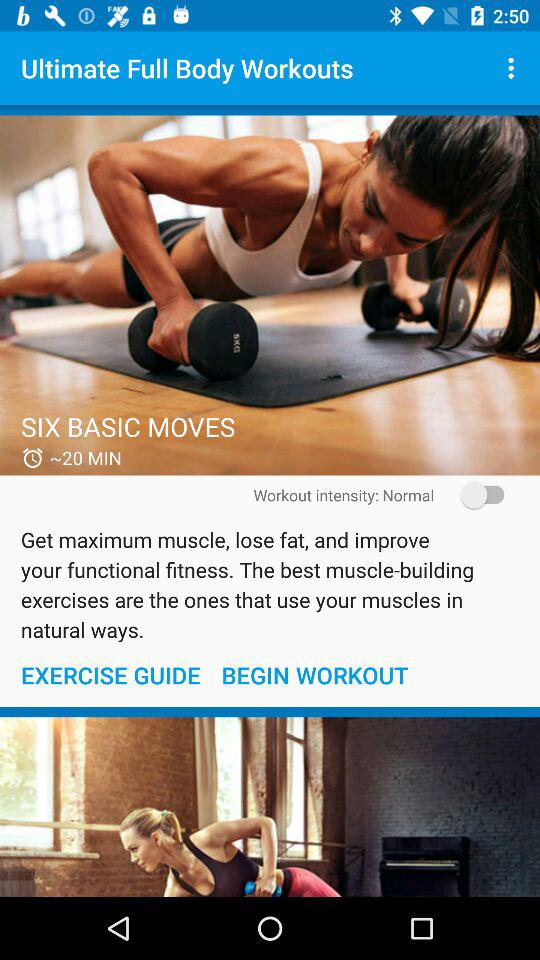What is the duration of "SIX BASIC MOVES"? The duration is 20 minutes. 